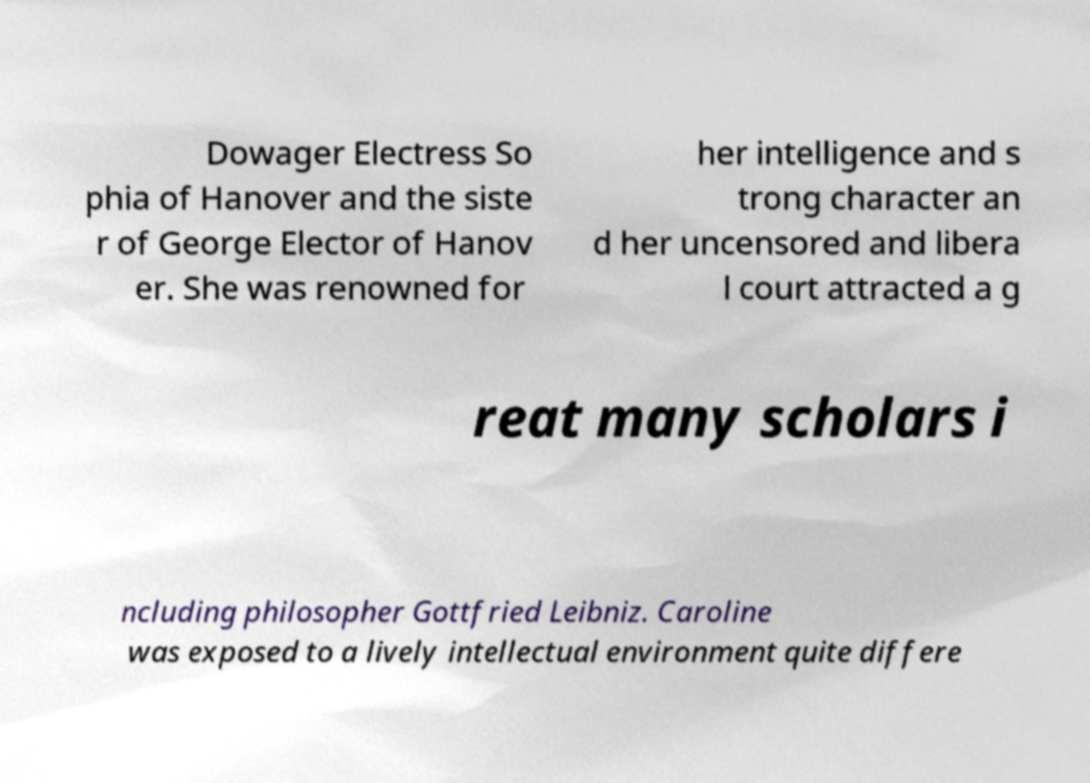Can you read and provide the text displayed in the image?This photo seems to have some interesting text. Can you extract and type it out for me? Dowager Electress So phia of Hanover and the siste r of George Elector of Hanov er. She was renowned for her intelligence and s trong character an d her uncensored and libera l court attracted a g reat many scholars i ncluding philosopher Gottfried Leibniz. Caroline was exposed to a lively intellectual environment quite differe 